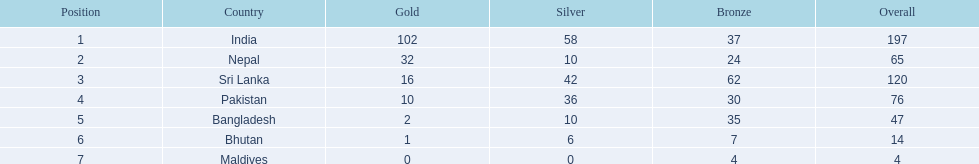Which nations played at the 1999 south asian games? India, Nepal, Sri Lanka, Pakistan, Bangladesh, Bhutan, Maldives. Which country is listed second in the table? Nepal. 